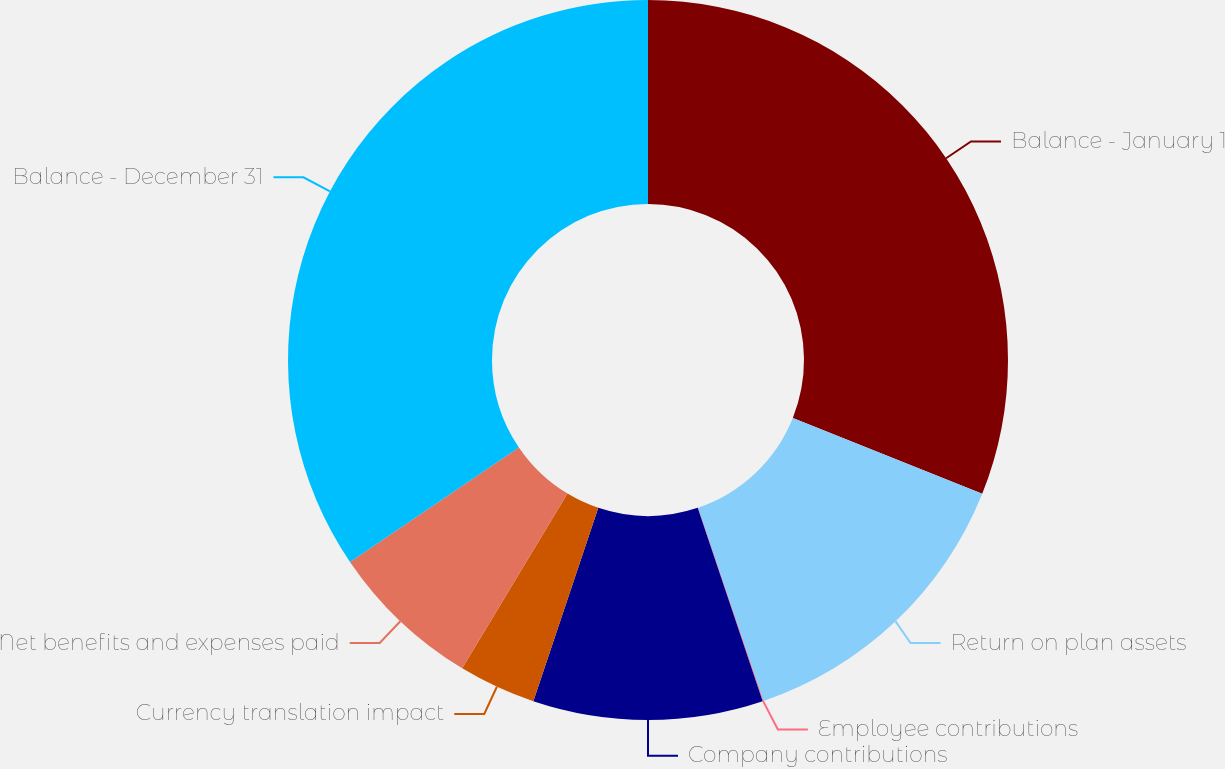Convert chart to OTSL. <chart><loc_0><loc_0><loc_500><loc_500><pie_chart><fcel>Balance - January 1<fcel>Return on plan assets<fcel>Employee contributions<fcel>Company contributions<fcel>Currency translation impact<fcel>Net benefits and expenses paid<fcel>Balance - December 31<nl><fcel>31.06%<fcel>13.74%<fcel>0.04%<fcel>10.32%<fcel>3.47%<fcel>6.89%<fcel>34.48%<nl></chart> 